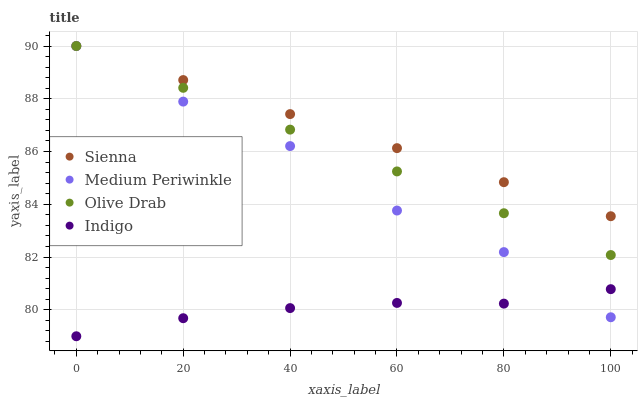Does Indigo have the minimum area under the curve?
Answer yes or no. Yes. Does Sienna have the maximum area under the curve?
Answer yes or no. Yes. Does Medium Periwinkle have the minimum area under the curve?
Answer yes or no. No. Does Medium Periwinkle have the maximum area under the curve?
Answer yes or no. No. Is Sienna the smoothest?
Answer yes or no. Yes. Is Medium Periwinkle the roughest?
Answer yes or no. Yes. Is Indigo the smoothest?
Answer yes or no. No. Is Indigo the roughest?
Answer yes or no. No. Does Indigo have the lowest value?
Answer yes or no. Yes. Does Medium Periwinkle have the lowest value?
Answer yes or no. No. Does Olive Drab have the highest value?
Answer yes or no. Yes. Does Indigo have the highest value?
Answer yes or no. No. Is Indigo less than Olive Drab?
Answer yes or no. Yes. Is Olive Drab greater than Indigo?
Answer yes or no. Yes. Does Olive Drab intersect Medium Periwinkle?
Answer yes or no. Yes. Is Olive Drab less than Medium Periwinkle?
Answer yes or no. No. Is Olive Drab greater than Medium Periwinkle?
Answer yes or no. No. Does Indigo intersect Olive Drab?
Answer yes or no. No. 